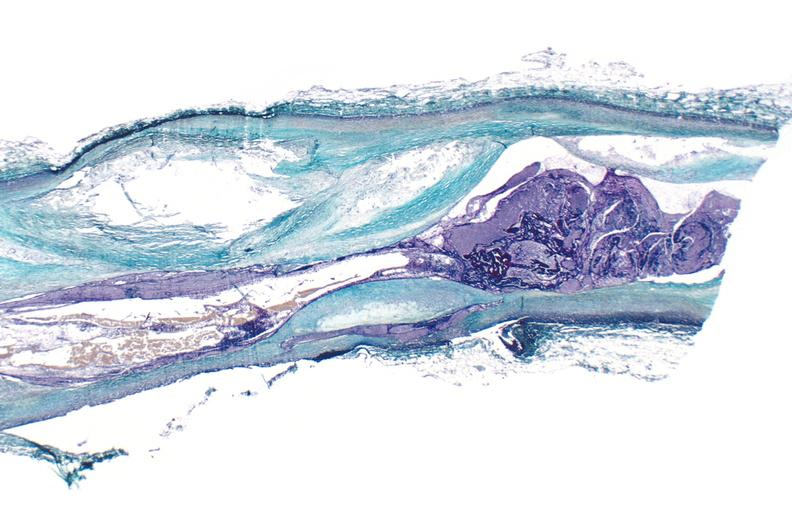does this image show coronary artery atherosclerosis, thrombosis longitudinal section?
Answer the question using a single word or phrase. Yes 